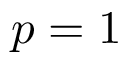Convert formula to latex. <formula><loc_0><loc_0><loc_500><loc_500>p = 1</formula> 